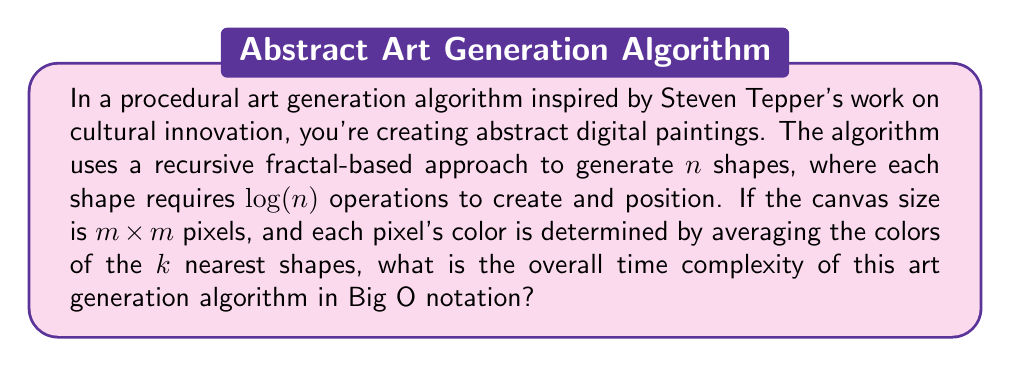Can you answer this question? To determine the overall time complexity, let's break down the algorithm into its main components:

1. Shape Generation:
   - Number of shapes: $n$
   - Operations per shape: $\log(n)$
   - Total complexity for shape generation: $O(n \log(n))$

2. Pixel Color Determination:
   - Canvas size: $m \times m$ pixels
   - For each pixel:
     a. Find $k$ nearest shapes: $O(n)$ (naive approach)
     b. Average colors: $O(k)$
   - Total complexity for pixel coloring: $O(m^2 \cdot (n + k))$

Combining these steps:

$$O(n \log(n) + m^2 \cdot (n + k))$$

To simplify this expression, we need to consider the relationships between $n$, $m$, and $k$:

- Typically, $n$ (number of shapes) would be much smaller than $m^2$ (total pixels)
- $k$ is likely a small constant value

Therefore, the dominant term will be $m^2 \cdot n$, as it grows faster than $n \log(n)$ and $m^2 \cdot k$.

We can thus simplify the complexity to:

$$O(m^2 \cdot n)$$

This represents a quadratic time complexity in terms of canvas size and linear in terms of the number of shapes.
Answer: $O(m^2 \cdot n)$ 